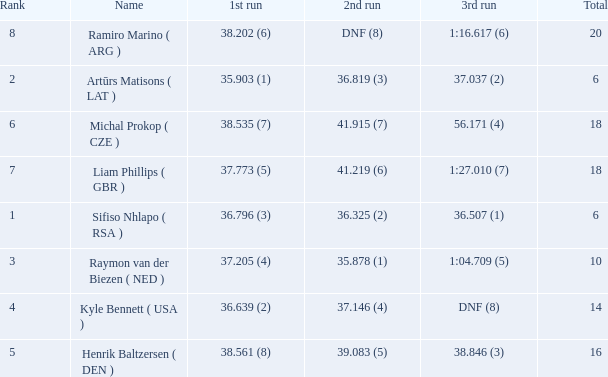Which 3rd run has rank of 8? 1:16.617 (6). 